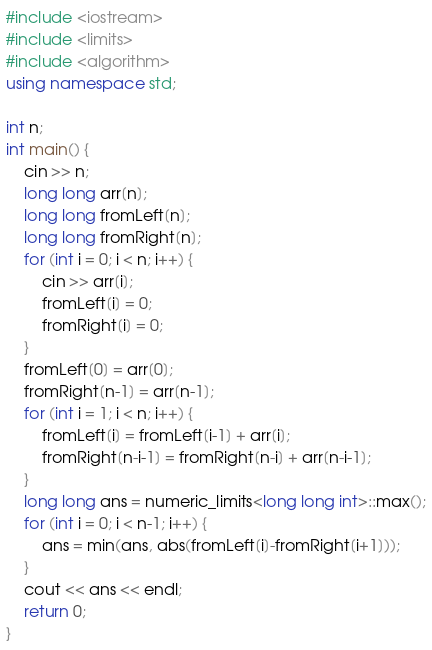<code> <loc_0><loc_0><loc_500><loc_500><_C++_>#include <iostream>
#include <limits>
#include <algorithm>
using namespace std;

int n;
int main() {
    cin >> n;
    long long arr[n];
    long long fromLeft[n];
    long long fromRight[n];
    for (int i = 0; i < n; i++) {
      	cin >> arr[i];
        fromLeft[i] = 0;
        fromRight[i] = 0;
    }
    fromLeft[0] = arr[0];
    fromRight[n-1] = arr[n-1];
    for (int i = 1; i < n; i++) {
        fromLeft[i] = fromLeft[i-1] + arr[i];
        fromRight[n-i-1] = fromRight[n-i] + arr[n-i-1];
    }
    long long ans = numeric_limits<long long int>::max();
    for (int i = 0; i < n-1; i++) {
        ans = min(ans, abs(fromLeft[i]-fromRight[i+1]));
    }
    cout << ans << endl;
    return 0;
}</code> 